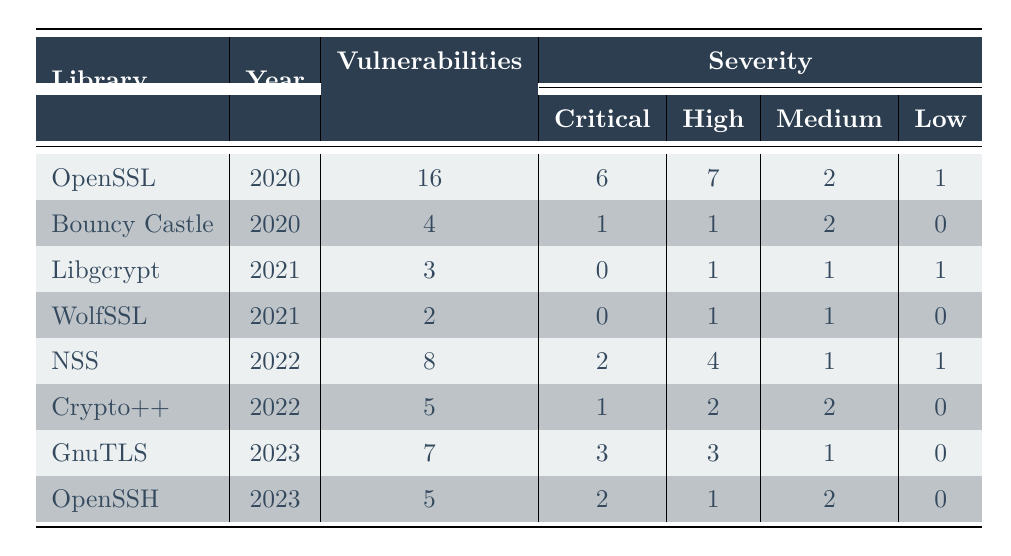What was the total number of vulnerabilities found in OpenSSL in 2020? In the table, OpenSSL is listed under the year 2020, and it shows that 16 vulnerabilities were found.
Answer: 16 Which library had the highest number of critical vulnerabilities in 2022? In 2022, NSS has 2 critical vulnerabilities and Crypto++ has 1. Hence, NSS had the highest number of critical vulnerabilities.
Answer: NSS What is the difference in the number of vulnerabilities found between OpenSSL in 2020 and GnuTLS in 2023? OpenSSL had 16 vulnerabilities in 2020 and GnuTLS had 7 vulnerabilities in 2023. The difference is 16 - 7 = 9.
Answer: 9 Did any library report zero critical vulnerabilities in 2021? Both Libgcrypt and WolfSSL reported 0 critical vulnerabilities in 2021. Therefore, yes, there are libraries with zero critical vulnerabilities.
Answer: Yes What was the average number of vulnerabilities found across all libraries in 2021? The total number of vulnerabilities found in 2021 is 3 (Libgcrypt) + 2 (WolfSSL) = 5. There are 2 libraries in 2021, so the average is 5 / 2 = 2.5.
Answer: 2.5 Which library experienced a noticeable increase in the number of vulnerabilities from 2020 to 2022? OpenSSL (16 in 2020) and NSS (8 in 2022) show changes, but other libraries either decrease or have little change. No noticeable increase meets the criteria.
Answer: No How many total vulnerabilities were found in all libraries combined across three years? Adding vulnerabilities from each year: 16 (OpenSSL) + 4 (Bouncy Castle) + 3 (Libgcrypt) + 2 (WolfSSL) + 8 (NSS) + 5 (Crypto++) + 7 (GnuTLS) + 5 (OpenSSH) = 50.
Answer: 50 In which year was the lowest total severity score for vulnerabilities found when considering all severity types? Combining severity scores for 2021 gives 3 (Libgcrypt) + 2 (WolfSSL) = 5, lower than any other year. Thus, 2021 has the lowest total severity score.
Answer: 2021 Which library had the highest vulnerability count with the highest severity classification (critical) in the dataset? OpenSSL had the highest number of critical vulnerabilities (6) among all libraries across the years.
Answer: OpenSSL 